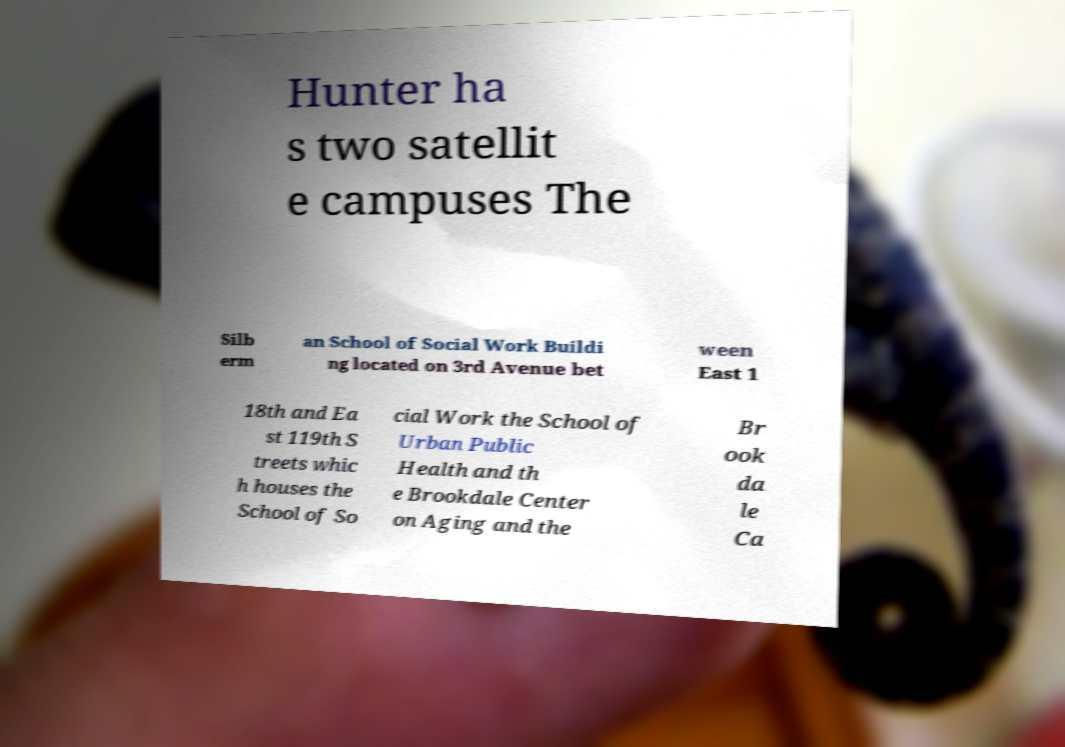I need the written content from this picture converted into text. Can you do that? Hunter ha s two satellit e campuses The Silb erm an School of Social Work Buildi ng located on 3rd Avenue bet ween East 1 18th and Ea st 119th S treets whic h houses the School of So cial Work the School of Urban Public Health and th e Brookdale Center on Aging and the Br ook da le Ca 